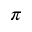<formula> <loc_0><loc_0><loc_500><loc_500>\pi</formula> 